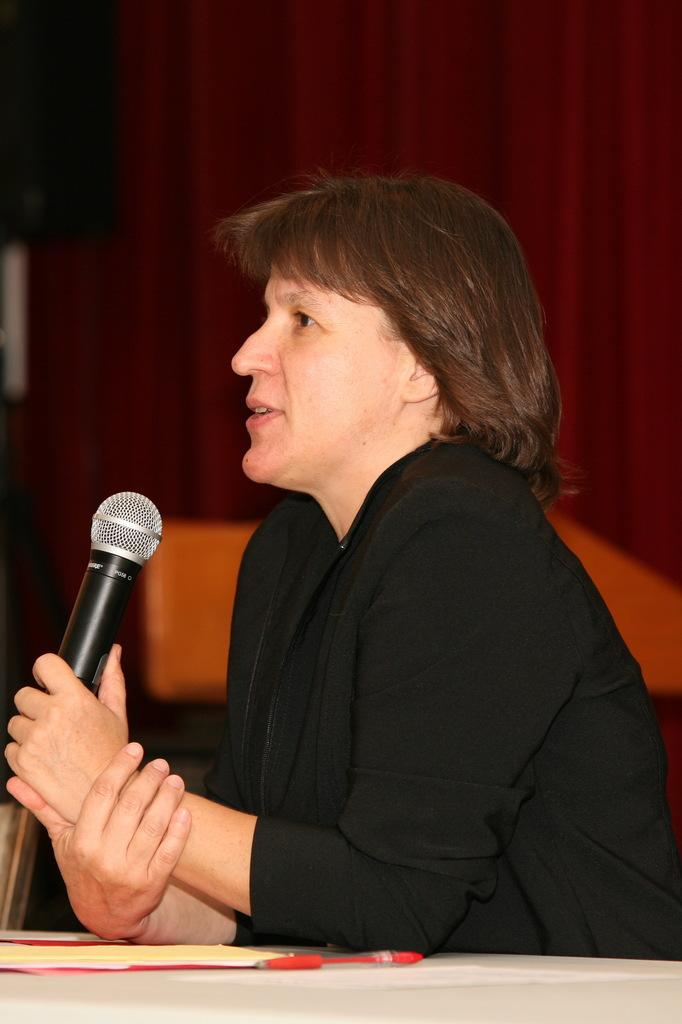Who is the main subject in the image? There is a person in the image. What is the person holding in the image? The person is holding a microphone. What is on the table in the image? There is a file and a pen on the table. What can be seen in the background of the image? There is a curtain in the background of the image. What is the queen doing in the image? There is no queen present in the image. How long does it take for the person to read the file in the image? The image does not provide information about the person reading the file or the time it takes to read it. 